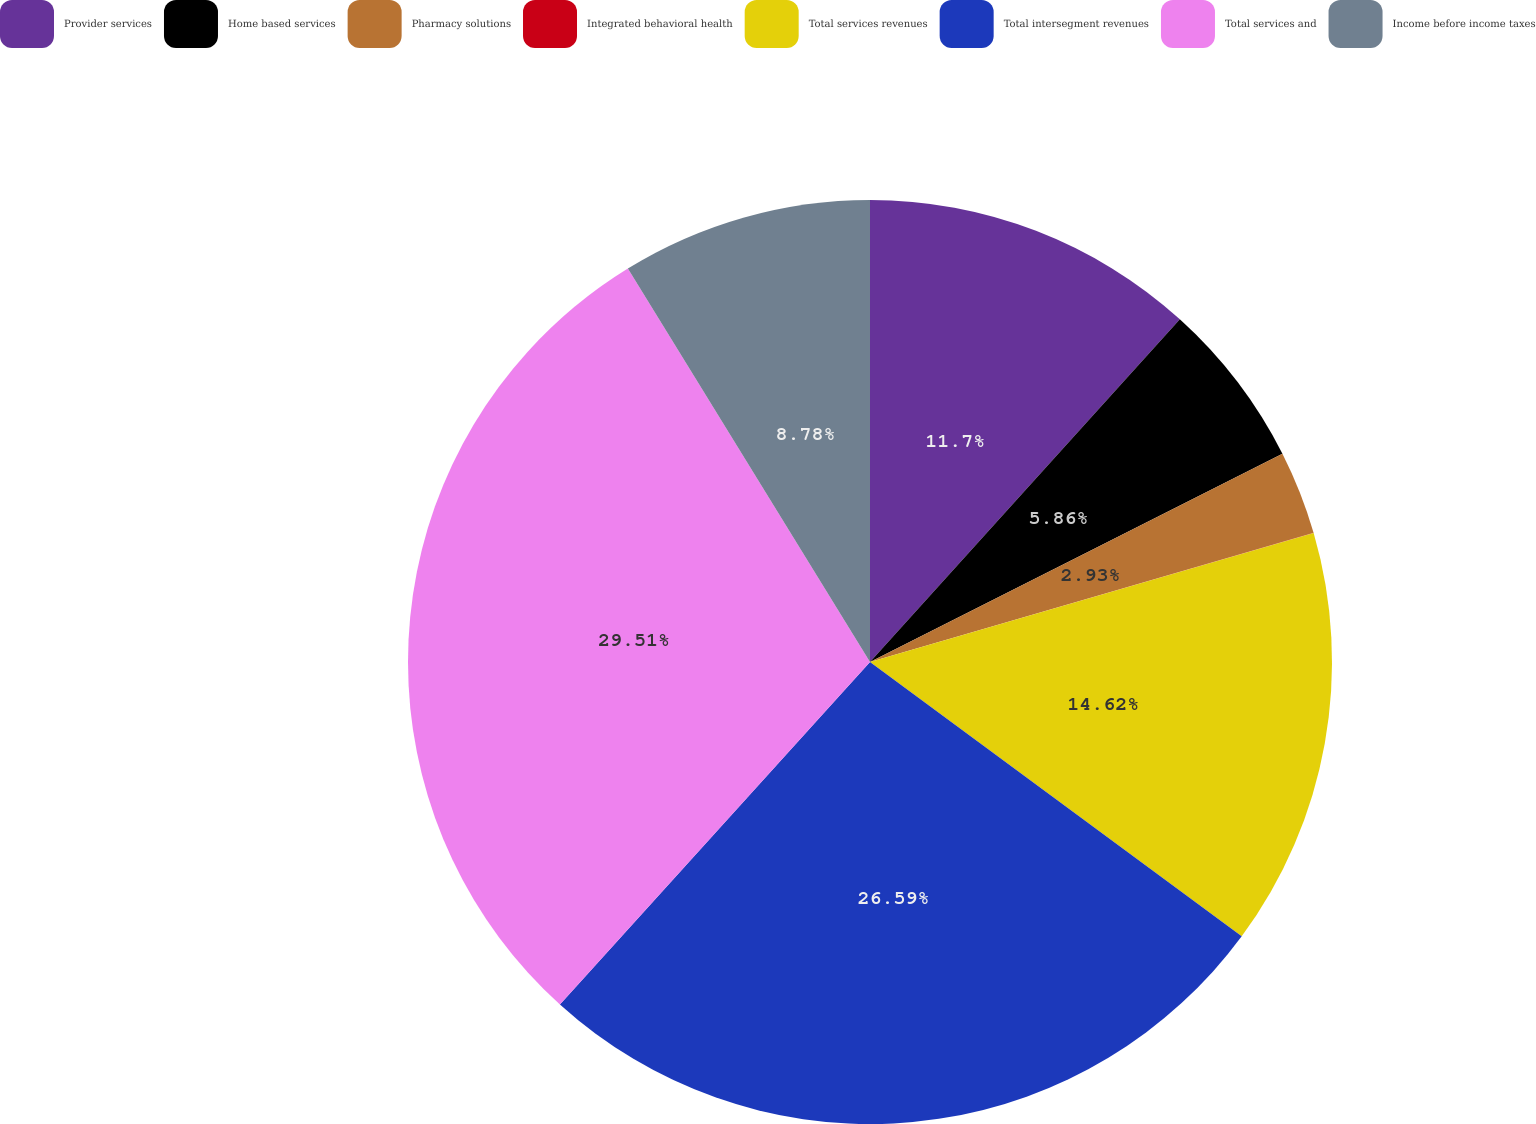Convert chart to OTSL. <chart><loc_0><loc_0><loc_500><loc_500><pie_chart><fcel>Provider services<fcel>Home based services<fcel>Pharmacy solutions<fcel>Integrated behavioral health<fcel>Total services revenues<fcel>Total intersegment revenues<fcel>Total services and<fcel>Income before income taxes<nl><fcel>11.7%<fcel>5.86%<fcel>2.93%<fcel>0.01%<fcel>14.62%<fcel>26.59%<fcel>29.51%<fcel>8.78%<nl></chart> 